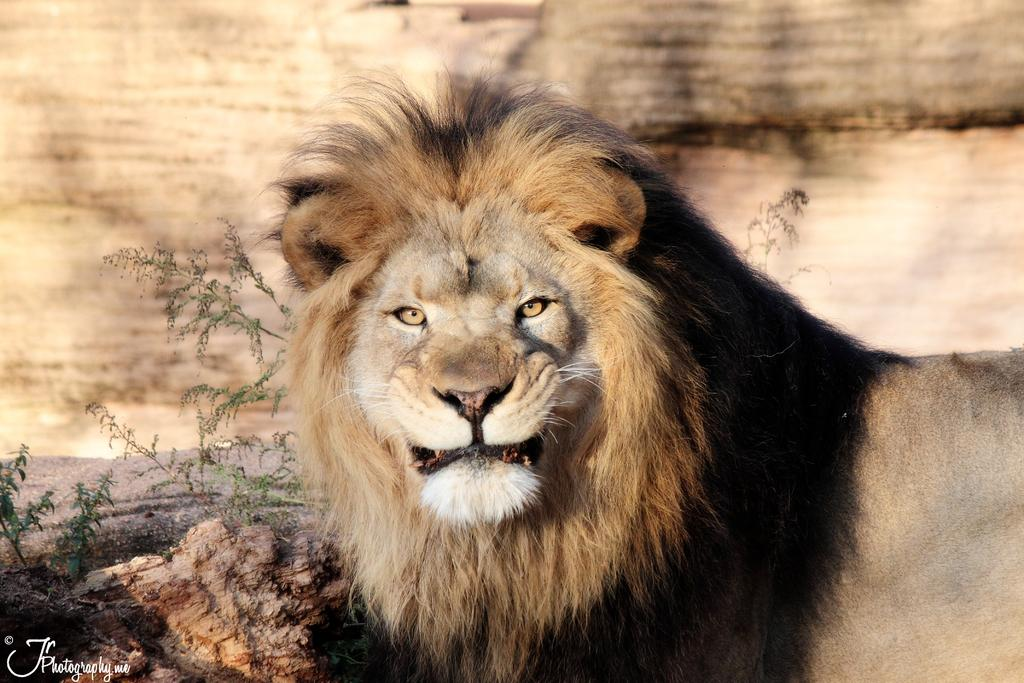What animal is in the foreground of the image? There is a lion in the foreground of the image. What can be seen in the background of the image? There appears to be a rock in the background of the image. What type of vegetation is visible in the image? There are small plants visible in the image. What object is located in the left corner of the image? There is a wooden object in the left corner of the image. Reasoning: Let' Let's think step by step in order to produce the conversation. We start by identifying the main subject in the image, which is the lion in the foreground. Then, we describe the background and other elements in the image, such as the rock, small plants, and wooden object. Each question is designed to elicit a specific detail about the image that is known from the provided facts. Absurd Question/Answer: Where is the dock located in the image? There is no dock present in the image. What type of chance is the lion taking in the image? The lion is not taking any chance in the image; it is simply depicted as a static figure. Where is the dock located in the image? There is no dock present in the image. What type of chance is the lion taking in the image? The lion is not taking any chance in the image; it is simply depicted as a static figure. 